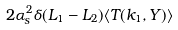<formula> <loc_0><loc_0><loc_500><loc_500>2 \alpha _ { s } ^ { 2 } \delta ( L _ { 1 } - L _ { 2 } ) \langle T ( k _ { 1 } , Y ) \rangle</formula> 